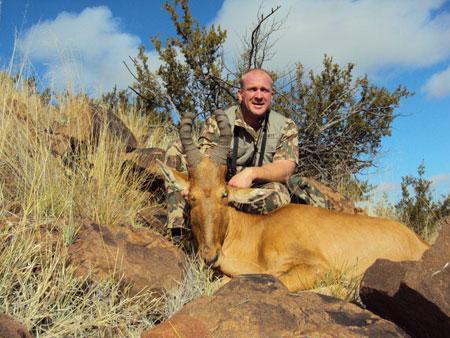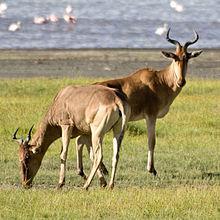The first image is the image on the left, the second image is the image on the right. Given the left and right images, does the statement "One of the images contains one man with a dead antelope." hold true? Answer yes or no. Yes. The first image is the image on the left, the second image is the image on the right. Considering the images on both sides, is "Just one hunter crouches behind a downed antelope in one of the images." valid? Answer yes or no. Yes. 